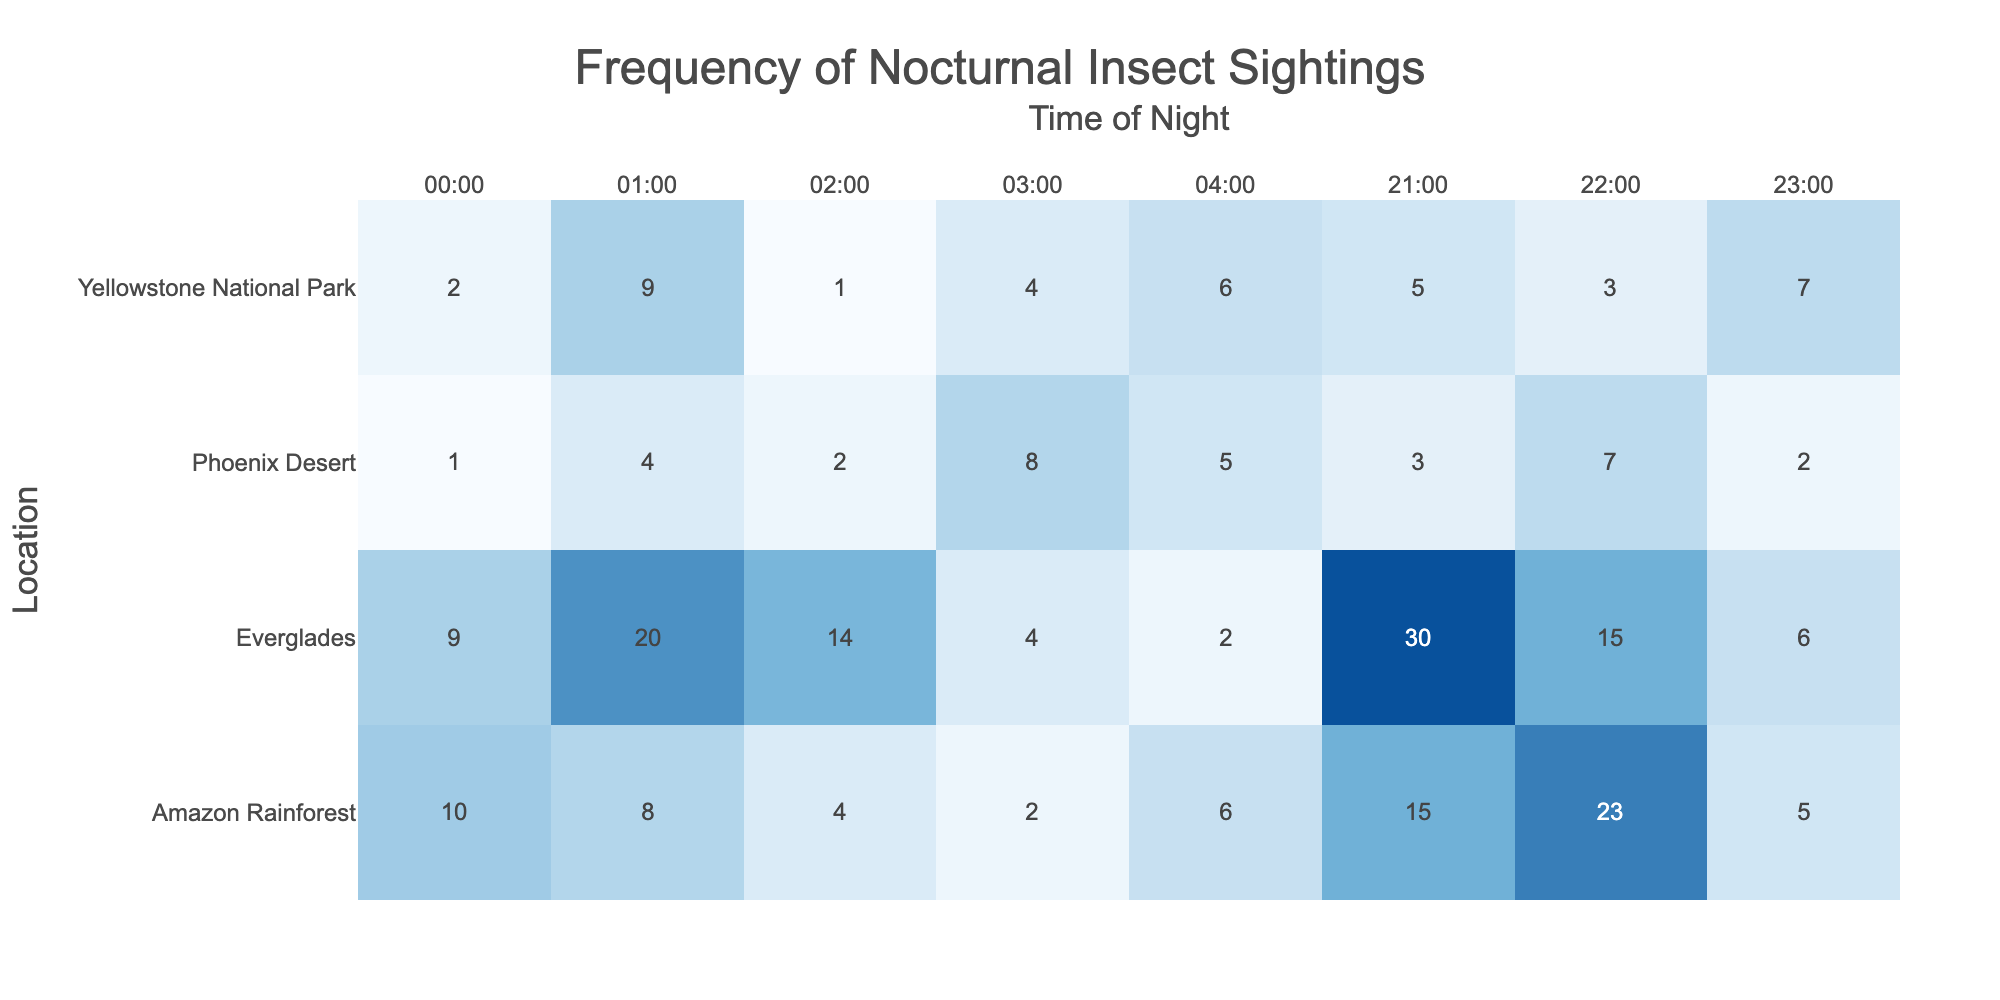What is the highest frequency of insect sightings recorded in the Everglades? In the table, the frequencies of insect sightings in the Everglades are 30, 15, 6, 9, 20, 14, 4, and 2. The highest value is 30.
Answer: 30 Which location had the lowest total nocturnal insect sightings throughout the night? By summing the frequencies of insect sightings for each location, we calculate: Amazon Rainforest (15 + 23 + 5 + 10 + 8 + 4 + 2 + 6 = 73), Phoenix Desert (3 + 7 + 2 + 1 + 4 + 2 + 8 + 5 = 32), Everglades (30 + 15 + 6 + 9 + 20 + 14 + 4 + 2 = 100), and Yellowstone National Park (5 + 3 + 7 + 2 + 9 + 1 + 4 + 6 = 37). The lowest total is for the Phoenix Desert with a total of 32 sightings.
Answer: Phoenix Desert How many sightings of Mantis religiosa occurred between 21:00 and 23:00 in the Amazon Rainforest? The frequencies of sightings for Mantis religiosa is only recorded at 01:00 with a frequency of 8. There are no sightings recorded for this species between 21:00 and 23:00. Thus, the total is 0.
Answer: 0 What was the average frequency of insect sightings across all locations and times? Adding up all sightings: 15 + 23 + 5 + 10 + 8 + 4 + 2 + 6 + 3 + 7 + 2 + 1 + 4 + 2 + 8 + 5 + 30 + 15 + 6 + 9 + 20 + 14 + 4 + 2 + 5 + 3 + 7 + 2 + 9 + 1 + 4 + 6 =  371. There are 32 data points (8 time points per 4 locations), so the average is 371/32 = 11.59.
Answer: 11.59 Did the Amazon Rainforest have more insect sightings at 22:00 than the Everglades at the same hour? The Amazon Rainforest had 23 sightings at 22:00, while the Everglades had 15 sightings at 22:00. Since 23 is greater than 15, the answer is yes.
Answer: Yes What location had the maximum frequency of sightings at 02:00? For 02:00, the frequencies are 4 for the Amazon Rainforest, 2 for the Phoenix Desert, 14 for the Everglades, and 1 for Yellowstone National Park. The highest frequency is 14 from the Everglades.
Answer: Everglades How many more sightings were recorded for Tenebrio molitor compared to Grylidae in the Phoenix Desert? Tenebrio molitor had 2 sightings at 23:00, while Grylidae had 8 sightings at 03:00. To find the difference, we calculate: 2 - 8 = -6, meaning Grylidae had 6 more sightings than Tenebrio molitor.
Answer: Grylidae had 6 more sightings Which insect species had a frequency of sightings between 5 and 10 inclusive, and at what time did it occur? Inspecting the table: the insects with sightings 5 to 10 are Anopheles gambiae (5), Arctia caja (10), and Pericallia matronula (6). These occurrences were at 23:00, 00:00, and 04:00 respectively.
Answer: Anopheles gambiae at 23:00, Arctia caja at 00:00, Pericallia matronula at 04:00 Which insect species had the maximum frequency at 21:00 across all locations? Observing 21:00 frequencies, we have 15 for Lucilia sericata, 3 for Nine-lined Skink, 30 for Psorophora ciliata, and 5 for Hesperiidae. The highest frequency is 30 from Psorophora ciliata in the Everglades.
Answer: Psorophora ciliata How does the total frequency of sightings in Yellowstone National Park compare to the other locations? The total for Yellowstone is 37. The totals for other locations are: Amazon Rainforest 73, Phoenix Desert 32, and Everglades 100. Yellowstone has fewer sightings than all other locations.
Answer: Yellowstone has the least sightings 